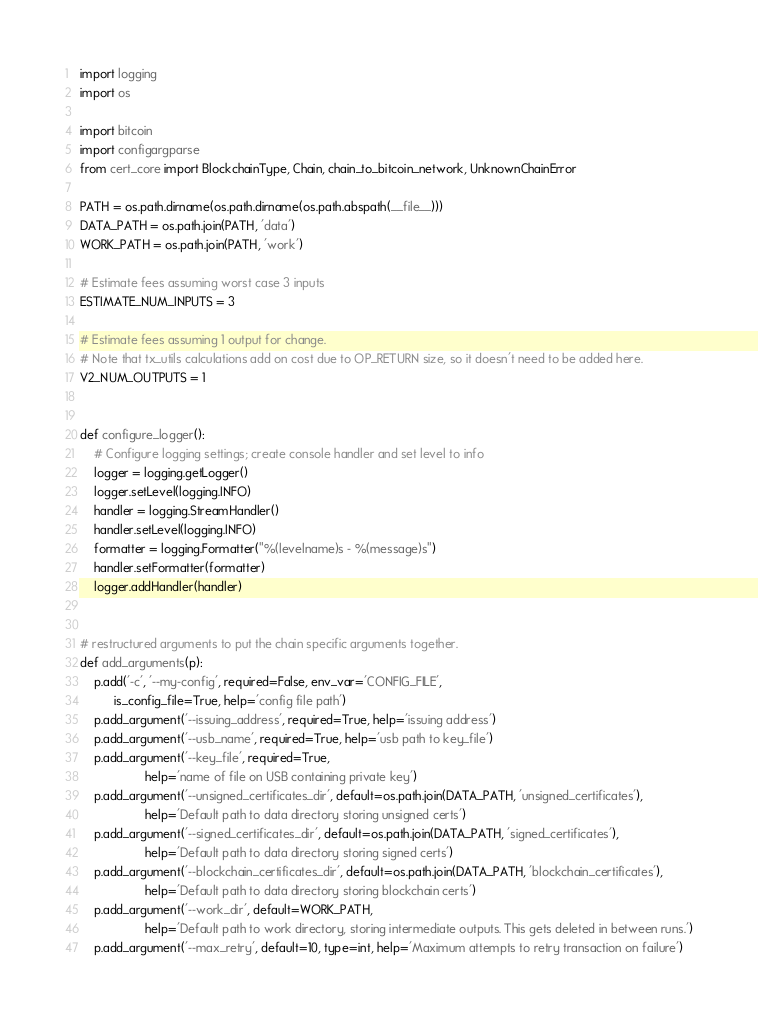Convert code to text. <code><loc_0><loc_0><loc_500><loc_500><_Python_>import logging
import os

import bitcoin
import configargparse
from cert_core import BlockchainType, Chain, chain_to_bitcoin_network, UnknownChainError

PATH = os.path.dirname(os.path.dirname(os.path.abspath(__file__)))
DATA_PATH = os.path.join(PATH, 'data')
WORK_PATH = os.path.join(PATH, 'work')

# Estimate fees assuming worst case 3 inputs
ESTIMATE_NUM_INPUTS = 3

# Estimate fees assuming 1 output for change.
# Note that tx_utils calculations add on cost due to OP_RETURN size, so it doesn't need to be added here.
V2_NUM_OUTPUTS = 1


def configure_logger():
    # Configure logging settings; create console handler and set level to info
    logger = logging.getLogger()
    logger.setLevel(logging.INFO)
    handler = logging.StreamHandler()
    handler.setLevel(logging.INFO)
    formatter = logging.Formatter("%(levelname)s - %(message)s")
    handler.setFormatter(formatter)
    logger.addHandler(handler)


# restructured arguments to put the chain specific arguments together.
def add_arguments(p):
    p.add('-c', '--my-config', required=False, env_var='CONFIG_FILE',
          is_config_file=True, help='config file path')
    p.add_argument('--issuing_address', required=True, help='issuing address')
    p.add_argument('--usb_name', required=True, help='usb path to key_file')
    p.add_argument('--key_file', required=True,
                   help='name of file on USB containing private key')
    p.add_argument('--unsigned_certificates_dir', default=os.path.join(DATA_PATH, 'unsigned_certificates'),
                   help='Default path to data directory storing unsigned certs')
    p.add_argument('--signed_certificates_dir', default=os.path.join(DATA_PATH, 'signed_certificates'),
                   help='Default path to data directory storing signed certs')
    p.add_argument('--blockchain_certificates_dir', default=os.path.join(DATA_PATH, 'blockchain_certificates'),
                   help='Default path to data directory storing blockchain certs')
    p.add_argument('--work_dir', default=WORK_PATH,
                   help='Default path to work directory, storing intermediate outputs. This gets deleted in between runs.')
    p.add_argument('--max_retry', default=10, type=int, help='Maximum attempts to retry transaction on failure')</code> 